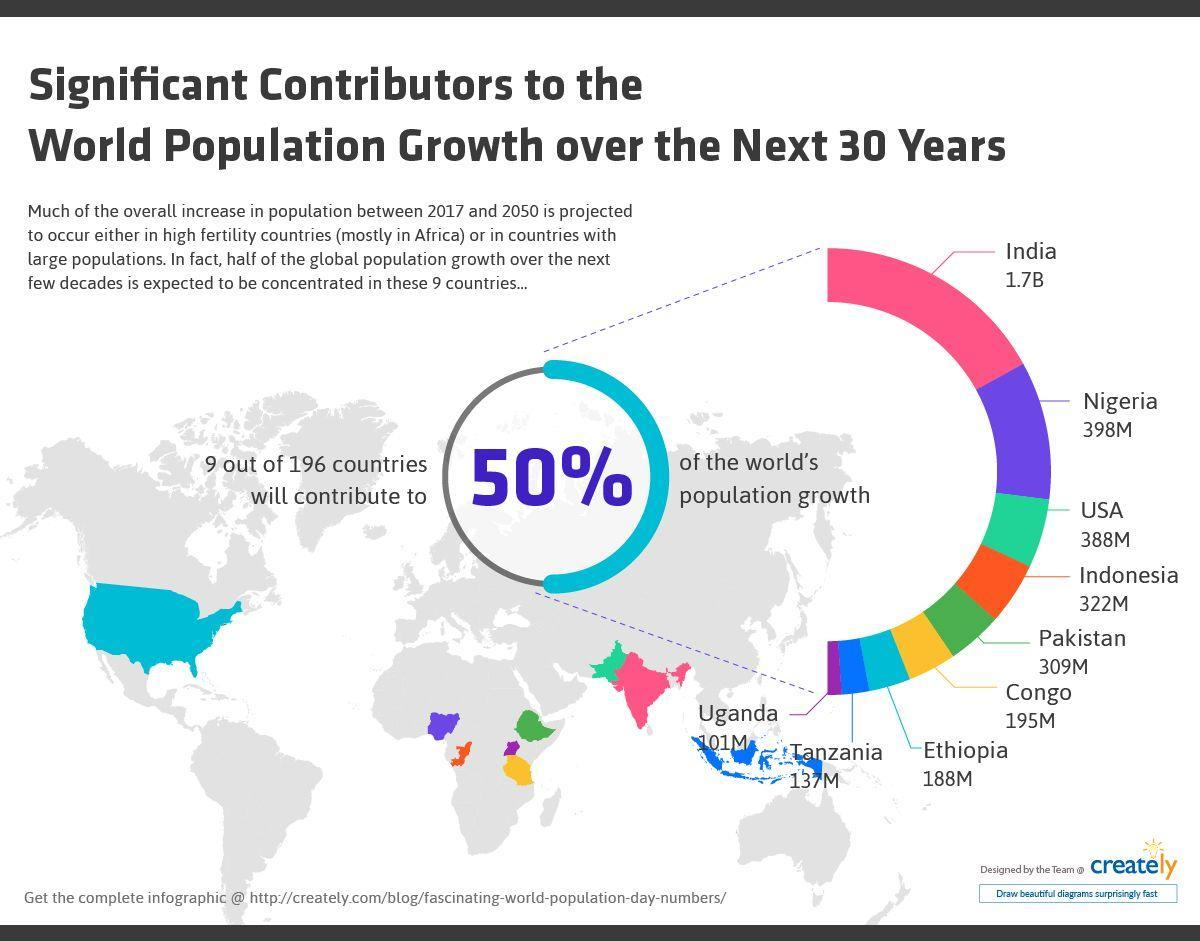What is the population of Pakistan and Indonesia, taken together over the next 30 years?
Answer the question with a short phrase. 631M What is the population of Ethiopia and Congo, taken together over the next 30 years? 383M What is the population of Nigeria and the USA, taken together over the next 30 years? 786M Which color used to represent India-orange, blue, pink, green? pink Which color used to represent Indonesia-pink, blue, orange, green? orange 